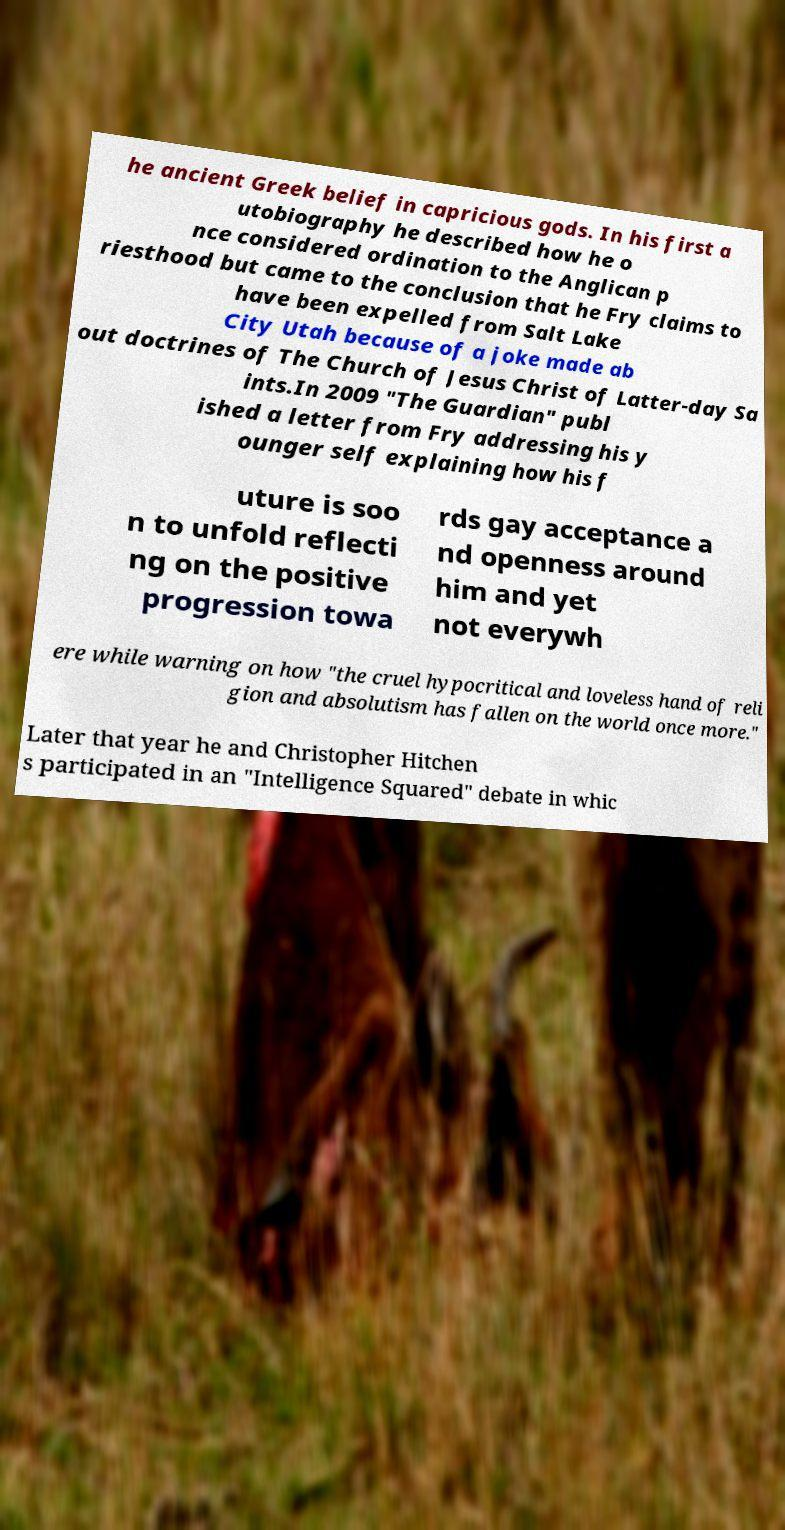There's text embedded in this image that I need extracted. Can you transcribe it verbatim? he ancient Greek belief in capricious gods. In his first a utobiography he described how he o nce considered ordination to the Anglican p riesthood but came to the conclusion that he Fry claims to have been expelled from Salt Lake City Utah because of a joke made ab out doctrines of The Church of Jesus Christ of Latter-day Sa ints.In 2009 "The Guardian" publ ished a letter from Fry addressing his y ounger self explaining how his f uture is soo n to unfold reflecti ng on the positive progression towa rds gay acceptance a nd openness around him and yet not everywh ere while warning on how "the cruel hypocritical and loveless hand of reli gion and absolutism has fallen on the world once more." Later that year he and Christopher Hitchen s participated in an "Intelligence Squared" debate in whic 